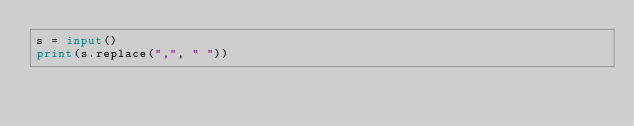<code> <loc_0><loc_0><loc_500><loc_500><_Python_>s = input()
print(s.replace(",", " "))</code> 